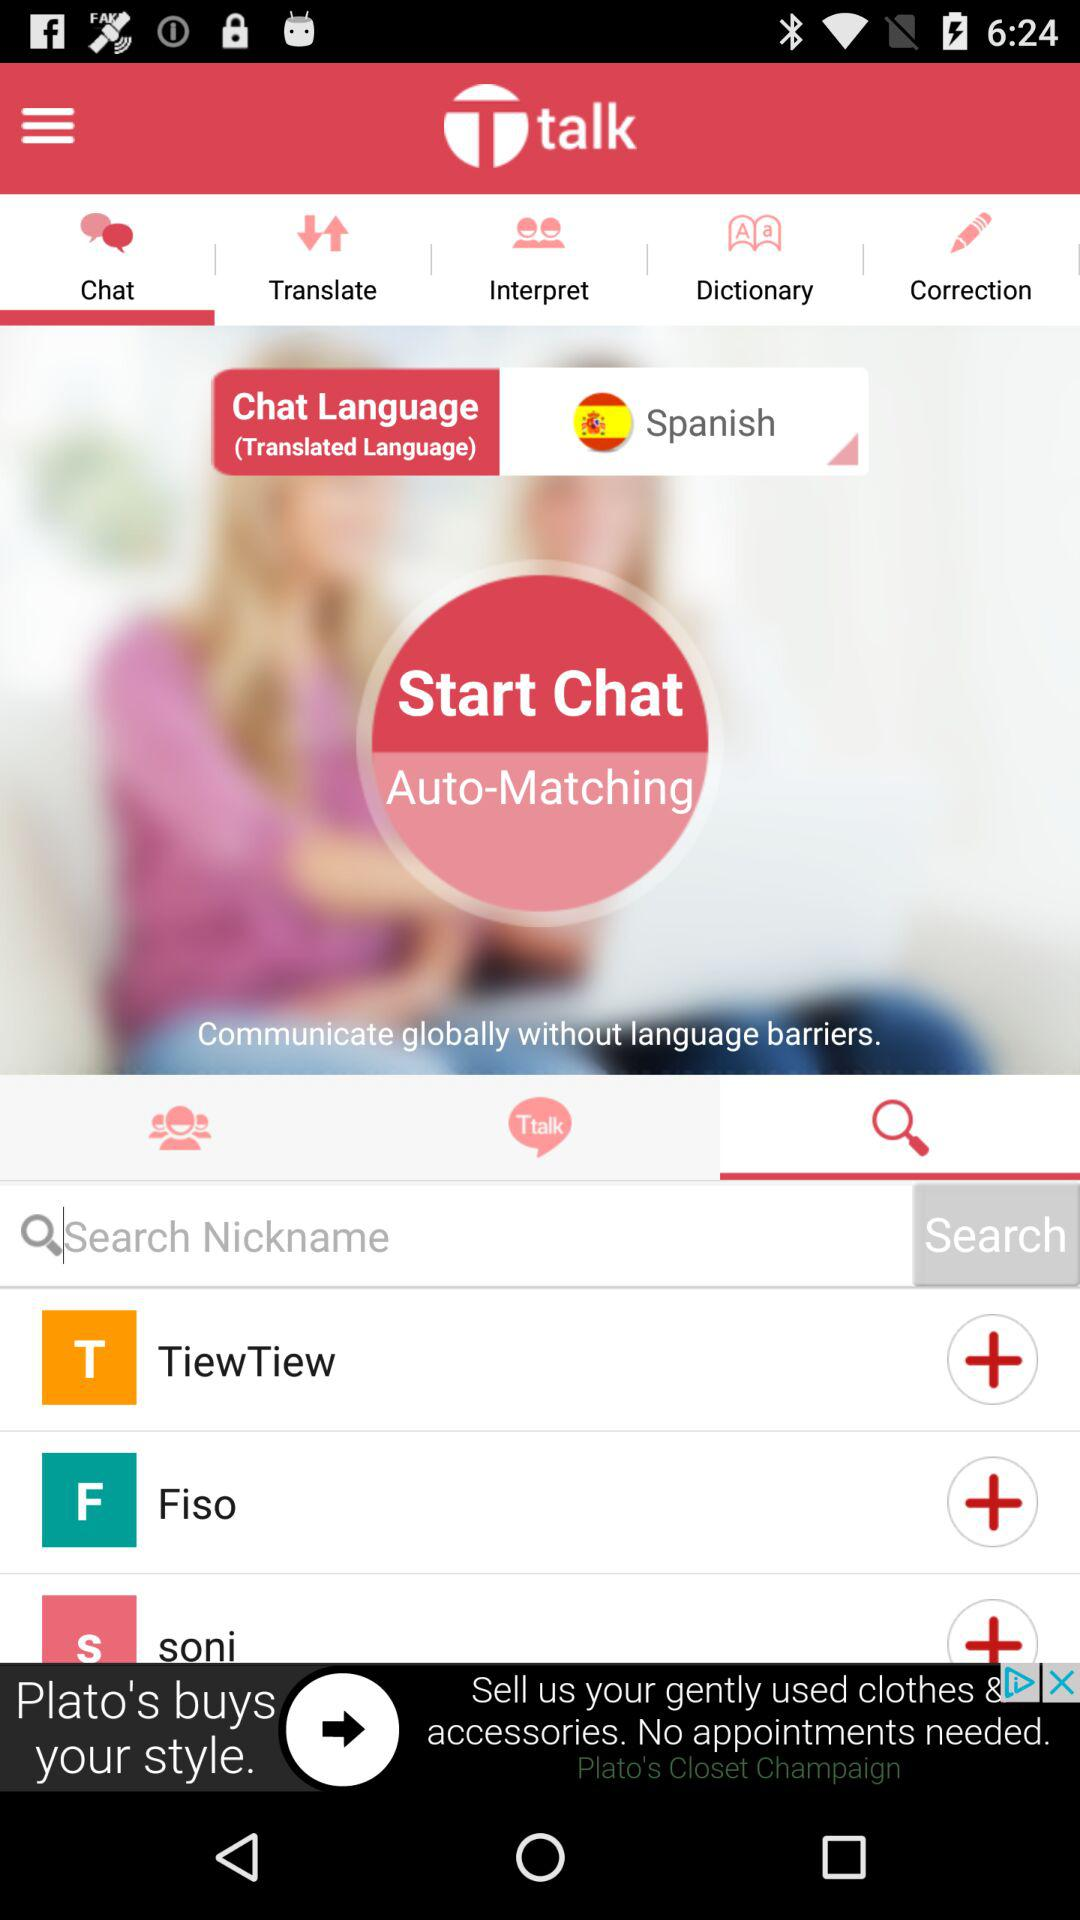Which tab is currently selected in the top bar? The tab that is currently selected in the top bar is "Chat". 